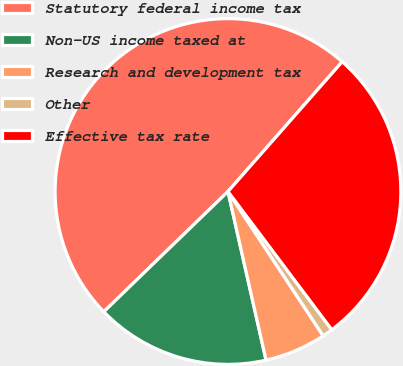Convert chart to OTSL. <chart><loc_0><loc_0><loc_500><loc_500><pie_chart><fcel>Statutory federal income tax<fcel>Non-US income taxed at<fcel>Research and development tax<fcel>Other<fcel>Effective tax rate<nl><fcel>48.73%<fcel>16.29%<fcel>5.75%<fcel>0.97%<fcel>28.26%<nl></chart> 